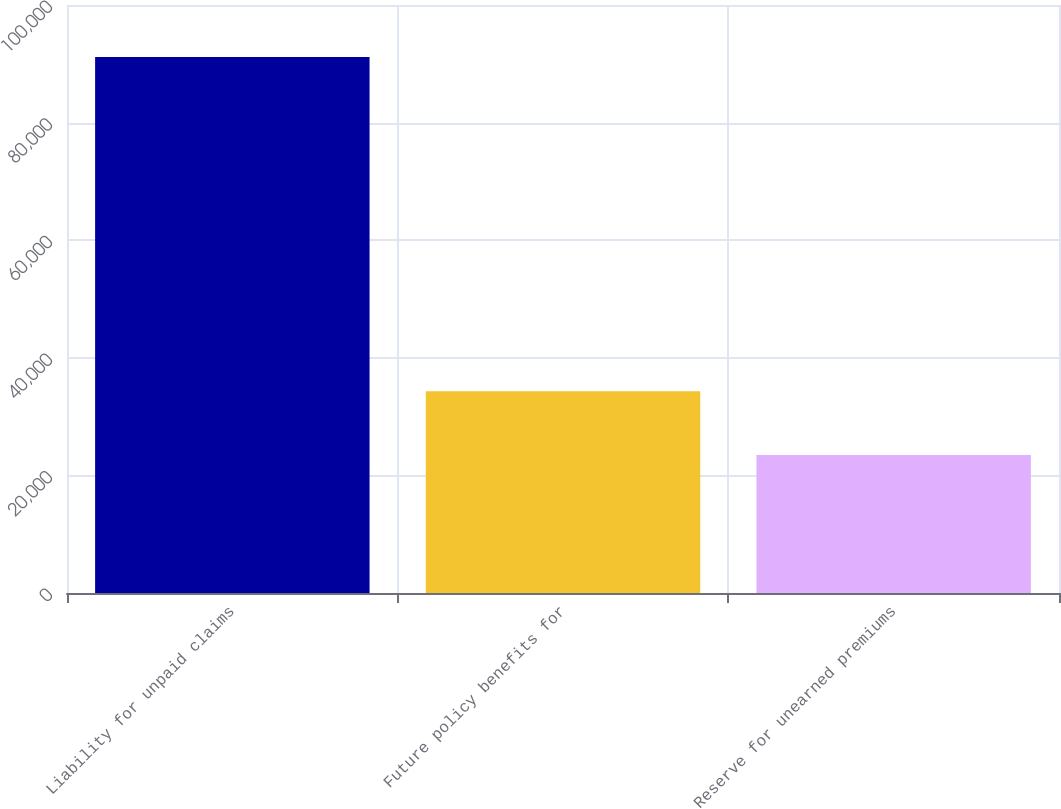Convert chart. <chart><loc_0><loc_0><loc_500><loc_500><bar_chart><fcel>Liability for unpaid claims<fcel>Future policy benefits for<fcel>Reserve for unearned premiums<nl><fcel>91145<fcel>34317<fcel>23465<nl></chart> 